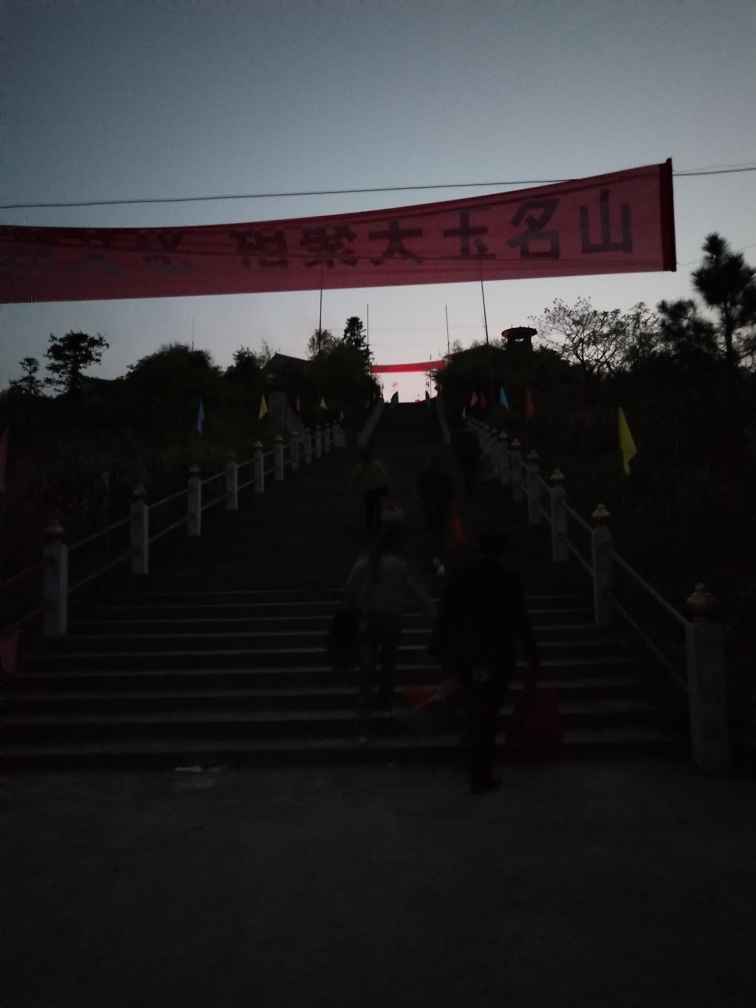Are there any quality issues with this image? Yes, the image exhibits several quality issues; it is underexposed, making it difficult to discern details, especially in the shadow areas. Additionally, the image appears to be grainy, which could be due to low light conditions or high ISO settings used during the capture. The composition also seems unbalanced with the banner and subjects in silhouette. 